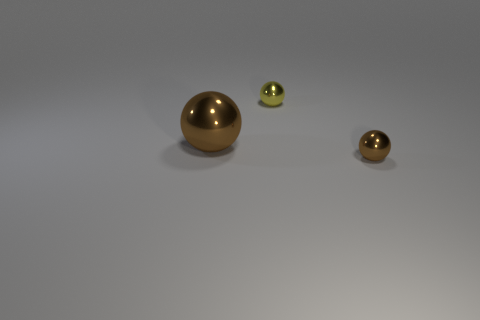There is a ball that is left of the tiny brown thing and in front of the small yellow shiny object; what is its size?
Offer a terse response. Large. What number of blocks are either small cyan rubber things or large brown objects?
Offer a very short reply. 0. There is a ball on the right side of the small sphere behind the tiny shiny sphere that is on the right side of the small yellow ball; what is its material?
Keep it short and to the point. Metal. There is another thing that is the same color as the big object; what is its material?
Ensure brevity in your answer.  Metal. How many small brown spheres are made of the same material as the yellow object?
Offer a very short reply. 1. Is the size of the brown object left of the yellow object the same as the small brown object?
Provide a succinct answer. No. There is another tiny object that is made of the same material as the yellow object; what is its color?
Provide a short and direct response. Brown. There is a yellow metal thing; how many balls are in front of it?
Keep it short and to the point. 2. Do the big shiny object behind the small brown object and the metallic thing on the right side of the small yellow metallic thing have the same color?
Keep it short and to the point. Yes. The other small thing that is the same shape as the tiny yellow metal object is what color?
Your response must be concise. Brown. 